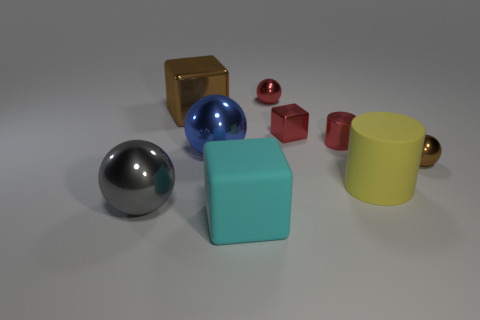There is a big block that is in front of the large metal thing in front of the yellow matte cylinder; is there a shiny cylinder that is on the left side of it? Upon examining the image, we can see various shapes and colors. In particular, there is a big turquoise block positioned in front of the larger glossy, silver metal sphere rather than in front of the yellow matte cylinder. To the left of this large block, there is no shiny cylinder; instead, the area to the left features a small glossy red cube and a small shiny gold cube. 